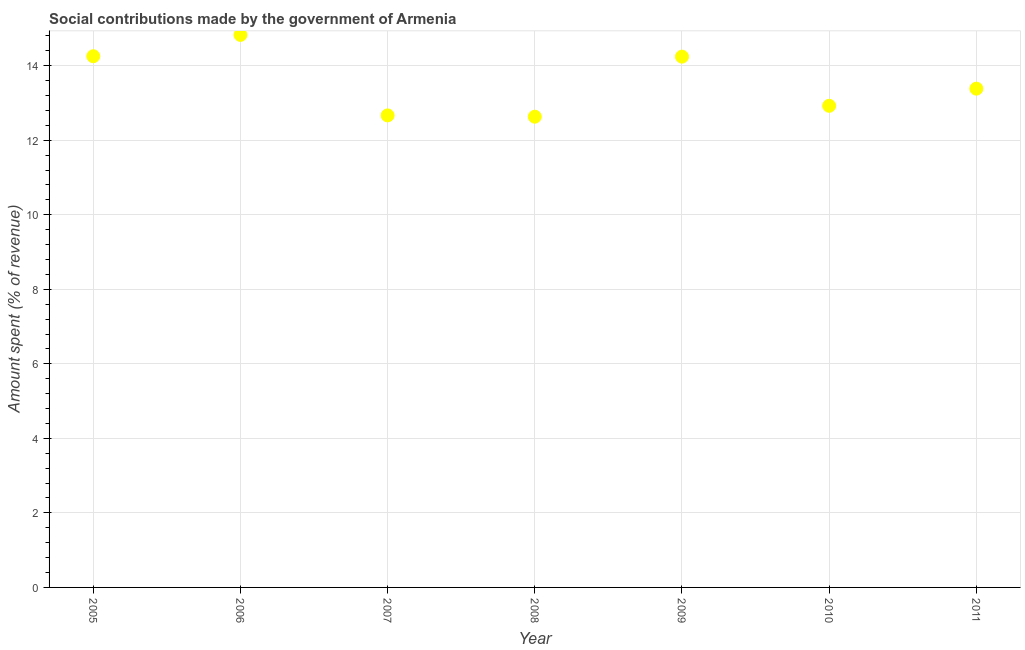What is the amount spent in making social contributions in 2009?
Your response must be concise. 14.24. Across all years, what is the maximum amount spent in making social contributions?
Provide a short and direct response. 14.83. Across all years, what is the minimum amount spent in making social contributions?
Give a very brief answer. 12.63. In which year was the amount spent in making social contributions maximum?
Make the answer very short. 2006. In which year was the amount spent in making social contributions minimum?
Provide a short and direct response. 2008. What is the sum of the amount spent in making social contributions?
Your response must be concise. 94.93. What is the difference between the amount spent in making social contributions in 2006 and 2008?
Provide a succinct answer. 2.19. What is the average amount spent in making social contributions per year?
Your answer should be compact. 13.56. What is the median amount spent in making social contributions?
Keep it short and to the point. 13.38. In how many years, is the amount spent in making social contributions greater than 10 %?
Give a very brief answer. 7. What is the ratio of the amount spent in making social contributions in 2006 to that in 2007?
Keep it short and to the point. 1.17. What is the difference between the highest and the second highest amount spent in making social contributions?
Your response must be concise. 0.57. Is the sum of the amount spent in making social contributions in 2005 and 2006 greater than the maximum amount spent in making social contributions across all years?
Your answer should be very brief. Yes. What is the difference between the highest and the lowest amount spent in making social contributions?
Make the answer very short. 2.19. In how many years, is the amount spent in making social contributions greater than the average amount spent in making social contributions taken over all years?
Make the answer very short. 3. Does the amount spent in making social contributions monotonically increase over the years?
Ensure brevity in your answer.  No. Are the values on the major ticks of Y-axis written in scientific E-notation?
Make the answer very short. No. Does the graph contain grids?
Your response must be concise. Yes. What is the title of the graph?
Offer a very short reply. Social contributions made by the government of Armenia. What is the label or title of the X-axis?
Your response must be concise. Year. What is the label or title of the Y-axis?
Ensure brevity in your answer.  Amount spent (% of revenue). What is the Amount spent (% of revenue) in 2005?
Your response must be concise. 14.25. What is the Amount spent (% of revenue) in 2006?
Offer a very short reply. 14.83. What is the Amount spent (% of revenue) in 2007?
Keep it short and to the point. 12.67. What is the Amount spent (% of revenue) in 2008?
Offer a very short reply. 12.63. What is the Amount spent (% of revenue) in 2009?
Provide a short and direct response. 14.24. What is the Amount spent (% of revenue) in 2010?
Your answer should be very brief. 12.92. What is the Amount spent (% of revenue) in 2011?
Offer a very short reply. 13.38. What is the difference between the Amount spent (% of revenue) in 2005 and 2006?
Offer a very short reply. -0.57. What is the difference between the Amount spent (% of revenue) in 2005 and 2007?
Make the answer very short. 1.59. What is the difference between the Amount spent (% of revenue) in 2005 and 2008?
Your answer should be very brief. 1.62. What is the difference between the Amount spent (% of revenue) in 2005 and 2009?
Provide a short and direct response. 0.01. What is the difference between the Amount spent (% of revenue) in 2005 and 2010?
Provide a short and direct response. 1.33. What is the difference between the Amount spent (% of revenue) in 2005 and 2011?
Give a very brief answer. 0.87. What is the difference between the Amount spent (% of revenue) in 2006 and 2007?
Provide a succinct answer. 2.16. What is the difference between the Amount spent (% of revenue) in 2006 and 2008?
Ensure brevity in your answer.  2.19. What is the difference between the Amount spent (% of revenue) in 2006 and 2009?
Provide a short and direct response. 0.58. What is the difference between the Amount spent (% of revenue) in 2006 and 2010?
Keep it short and to the point. 1.9. What is the difference between the Amount spent (% of revenue) in 2006 and 2011?
Offer a terse response. 1.44. What is the difference between the Amount spent (% of revenue) in 2007 and 2008?
Give a very brief answer. 0.04. What is the difference between the Amount spent (% of revenue) in 2007 and 2009?
Provide a short and direct response. -1.58. What is the difference between the Amount spent (% of revenue) in 2007 and 2010?
Give a very brief answer. -0.26. What is the difference between the Amount spent (% of revenue) in 2007 and 2011?
Offer a terse response. -0.72. What is the difference between the Amount spent (% of revenue) in 2008 and 2009?
Provide a succinct answer. -1.61. What is the difference between the Amount spent (% of revenue) in 2008 and 2010?
Ensure brevity in your answer.  -0.29. What is the difference between the Amount spent (% of revenue) in 2008 and 2011?
Provide a succinct answer. -0.75. What is the difference between the Amount spent (% of revenue) in 2009 and 2010?
Ensure brevity in your answer.  1.32. What is the difference between the Amount spent (% of revenue) in 2009 and 2011?
Ensure brevity in your answer.  0.86. What is the difference between the Amount spent (% of revenue) in 2010 and 2011?
Provide a short and direct response. -0.46. What is the ratio of the Amount spent (% of revenue) in 2005 to that in 2006?
Offer a very short reply. 0.96. What is the ratio of the Amount spent (% of revenue) in 2005 to that in 2008?
Your response must be concise. 1.13. What is the ratio of the Amount spent (% of revenue) in 2005 to that in 2009?
Provide a succinct answer. 1. What is the ratio of the Amount spent (% of revenue) in 2005 to that in 2010?
Your answer should be compact. 1.1. What is the ratio of the Amount spent (% of revenue) in 2005 to that in 2011?
Your response must be concise. 1.06. What is the ratio of the Amount spent (% of revenue) in 2006 to that in 2007?
Your answer should be very brief. 1.17. What is the ratio of the Amount spent (% of revenue) in 2006 to that in 2008?
Provide a succinct answer. 1.17. What is the ratio of the Amount spent (% of revenue) in 2006 to that in 2009?
Ensure brevity in your answer.  1.04. What is the ratio of the Amount spent (% of revenue) in 2006 to that in 2010?
Keep it short and to the point. 1.15. What is the ratio of the Amount spent (% of revenue) in 2006 to that in 2011?
Offer a terse response. 1.11. What is the ratio of the Amount spent (% of revenue) in 2007 to that in 2008?
Give a very brief answer. 1. What is the ratio of the Amount spent (% of revenue) in 2007 to that in 2009?
Offer a very short reply. 0.89. What is the ratio of the Amount spent (% of revenue) in 2007 to that in 2010?
Your answer should be very brief. 0.98. What is the ratio of the Amount spent (% of revenue) in 2007 to that in 2011?
Offer a terse response. 0.95. What is the ratio of the Amount spent (% of revenue) in 2008 to that in 2009?
Keep it short and to the point. 0.89. What is the ratio of the Amount spent (% of revenue) in 2008 to that in 2010?
Provide a succinct answer. 0.98. What is the ratio of the Amount spent (% of revenue) in 2008 to that in 2011?
Provide a succinct answer. 0.94. What is the ratio of the Amount spent (% of revenue) in 2009 to that in 2010?
Offer a very short reply. 1.1. What is the ratio of the Amount spent (% of revenue) in 2009 to that in 2011?
Keep it short and to the point. 1.06. What is the ratio of the Amount spent (% of revenue) in 2010 to that in 2011?
Give a very brief answer. 0.97. 